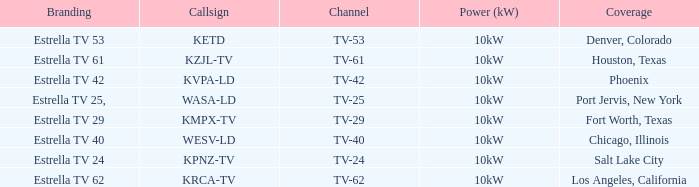Which city did kpnz-tv provide coverage for? Salt Lake City. 